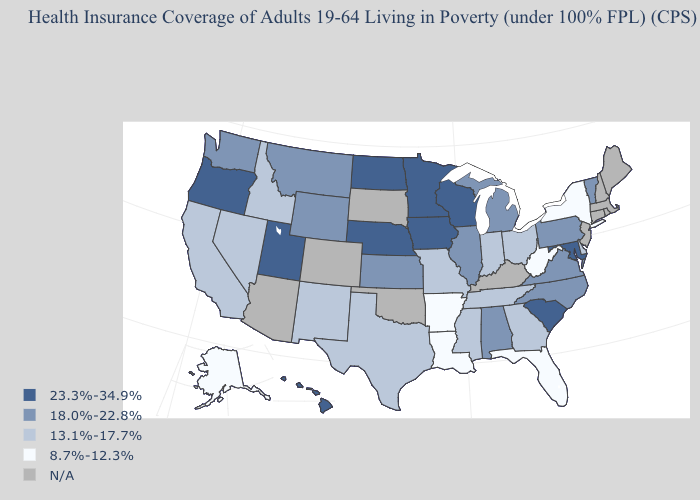What is the value of Virginia?
Keep it brief. 18.0%-22.8%. Among the states that border Alabama , does Florida have the lowest value?
Answer briefly. Yes. Which states hav the highest value in the West?
Keep it brief. Hawaii, Oregon, Utah. What is the value of Nebraska?
Keep it brief. 23.3%-34.9%. What is the lowest value in the MidWest?
Concise answer only. 13.1%-17.7%. What is the value of South Carolina?
Give a very brief answer. 23.3%-34.9%. What is the value of Alaska?
Write a very short answer. 8.7%-12.3%. What is the value of Maryland?
Be succinct. 23.3%-34.9%. What is the value of Florida?
Keep it brief. 8.7%-12.3%. Does New Mexico have the lowest value in the USA?
Be succinct. No. What is the highest value in the USA?
Write a very short answer. 23.3%-34.9%. How many symbols are there in the legend?
Be succinct. 5. What is the highest value in the USA?
Quick response, please. 23.3%-34.9%. Which states hav the highest value in the Northeast?
Keep it brief. Pennsylvania, Vermont. 